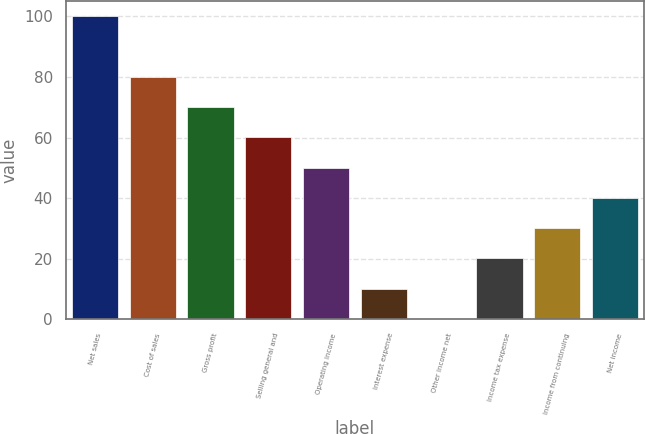Convert chart. <chart><loc_0><loc_0><loc_500><loc_500><bar_chart><fcel>Net sales<fcel>Cost of sales<fcel>Gross profit<fcel>Selling general and<fcel>Operating income<fcel>Interest expense<fcel>Other income net<fcel>Income tax expense<fcel>Income from continuing<fcel>Net income<nl><fcel>100<fcel>80.02<fcel>70.03<fcel>60.04<fcel>50.05<fcel>10.09<fcel>0.1<fcel>20.08<fcel>30.07<fcel>40.06<nl></chart> 